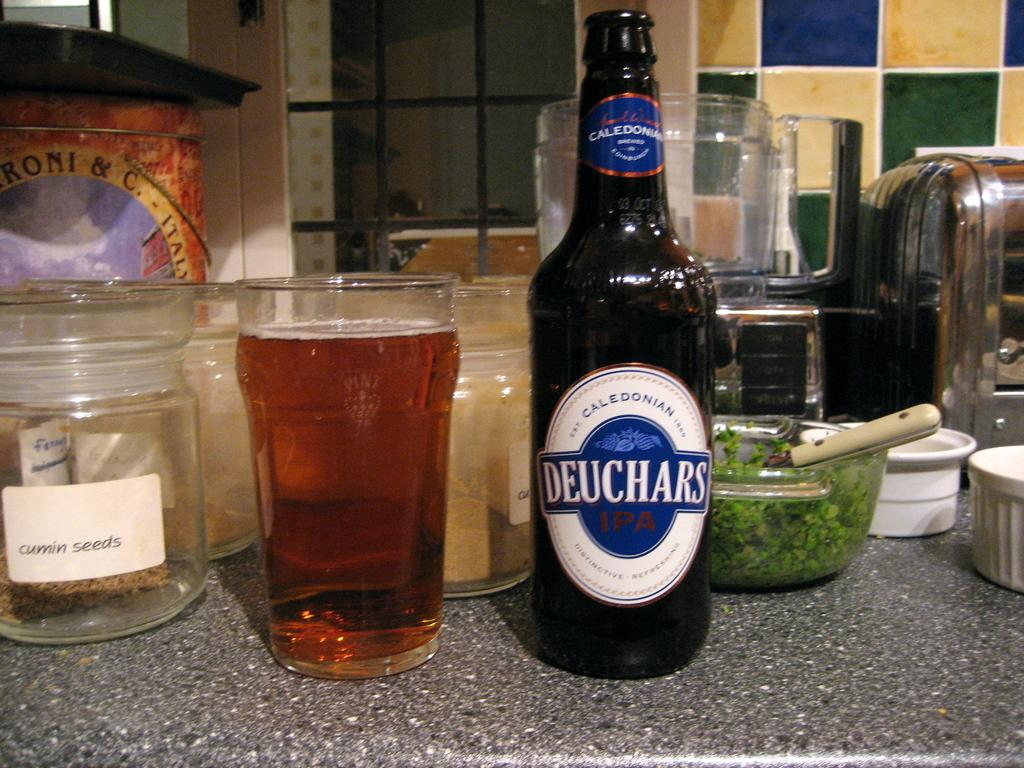<image>
Give a short and clear explanation of the subsequent image. a bottle of deuchars ipa with the words 'caledonian brewed' on the top label 